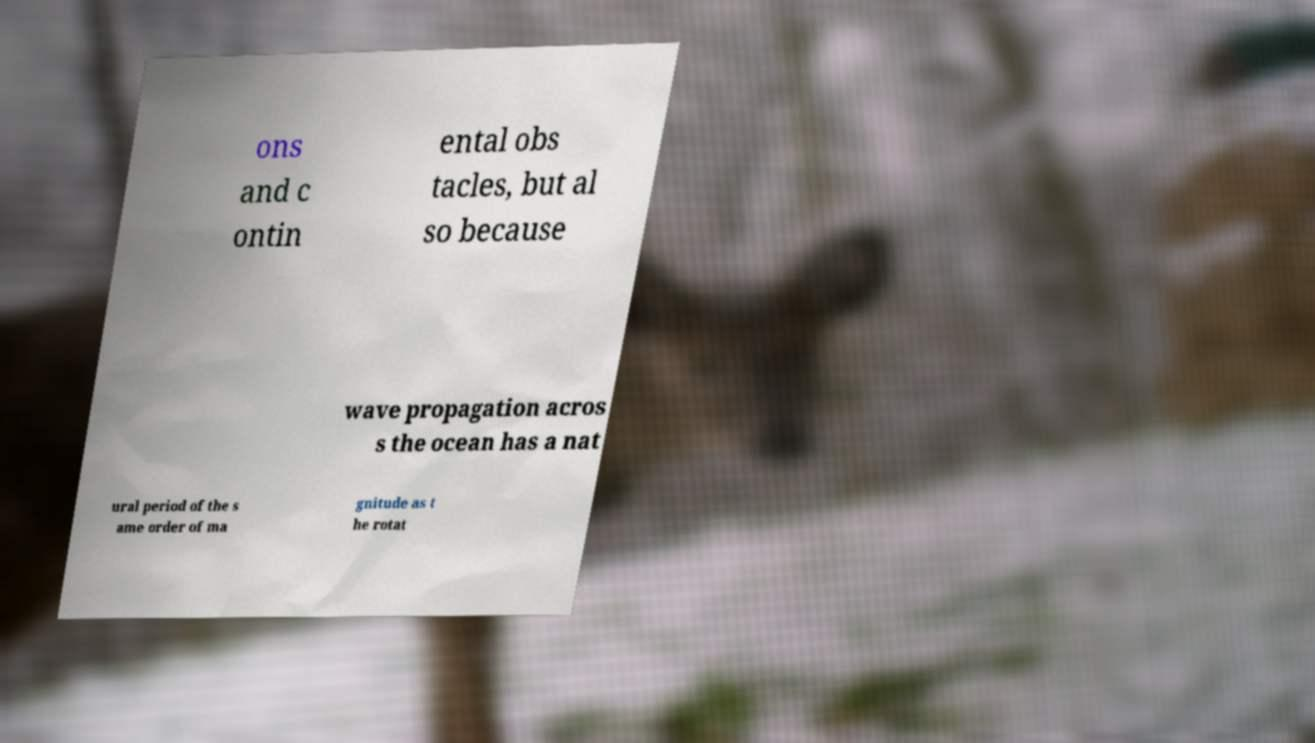Please identify and transcribe the text found in this image. ons and c ontin ental obs tacles, but al so because wave propagation acros s the ocean has a nat ural period of the s ame order of ma gnitude as t he rotat 